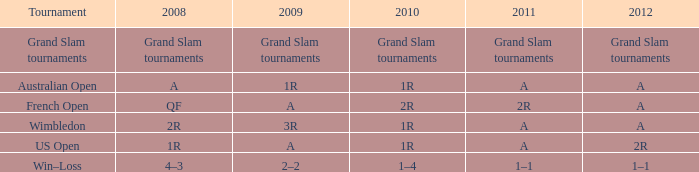Name the 2011 when 2010 is 2r 2R. 